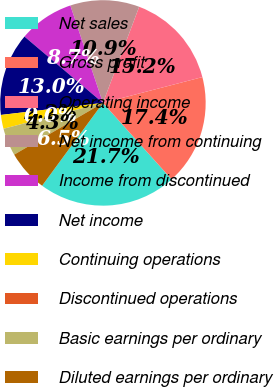Convert chart to OTSL. <chart><loc_0><loc_0><loc_500><loc_500><pie_chart><fcel>Net sales<fcel>Gross profit<fcel>Operating income<fcel>Net income from continuing<fcel>Income from discontinued<fcel>Net income<fcel>Continuing operations<fcel>Discontinued operations<fcel>Basic earnings per ordinary<fcel>Diluted earnings per ordinary<nl><fcel>21.74%<fcel>17.39%<fcel>15.22%<fcel>10.87%<fcel>8.7%<fcel>13.04%<fcel>2.18%<fcel>0.0%<fcel>4.35%<fcel>6.52%<nl></chart> 